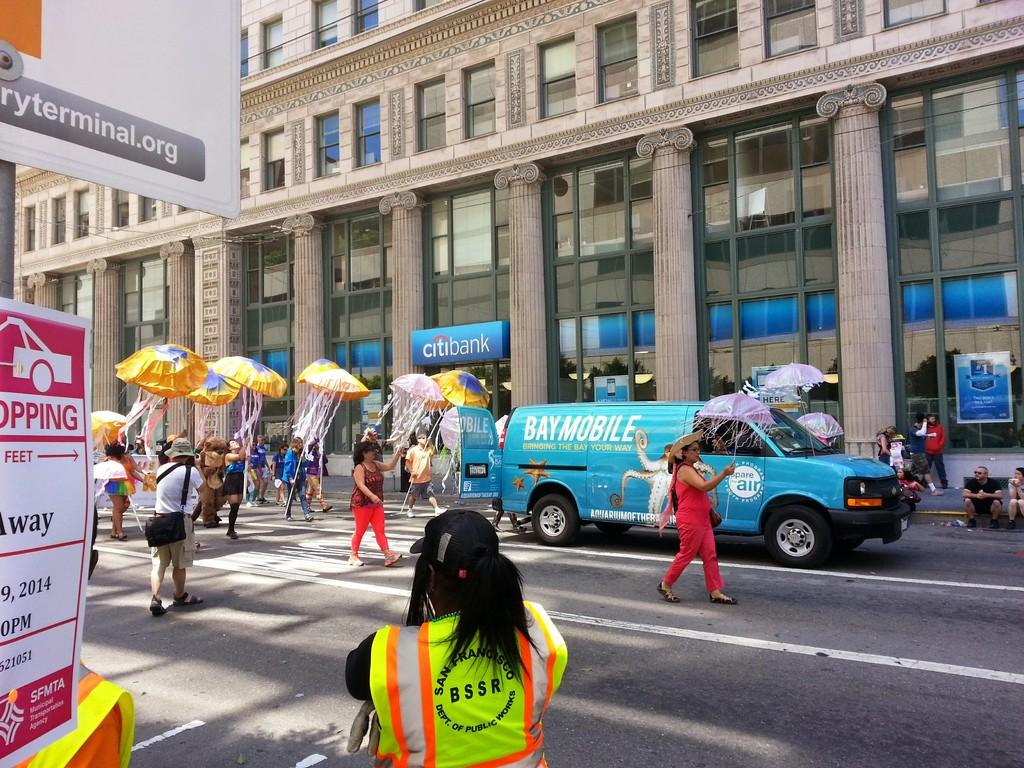<image>
Relay a brief, clear account of the picture shown. Blue Bay Mobile van rolling down the street with a parade. 